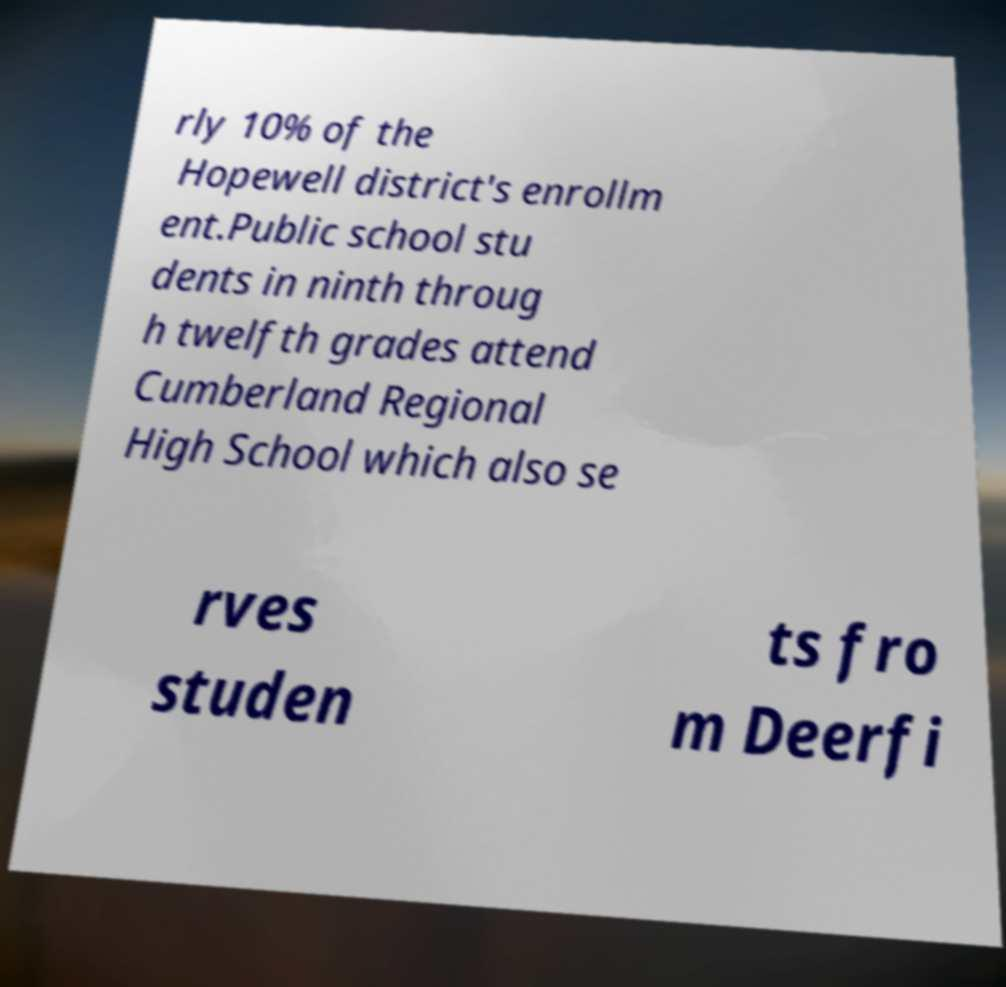Please read and relay the text visible in this image. What does it say? rly 10% of the Hopewell district's enrollm ent.Public school stu dents in ninth throug h twelfth grades attend Cumberland Regional High School which also se rves studen ts fro m Deerfi 